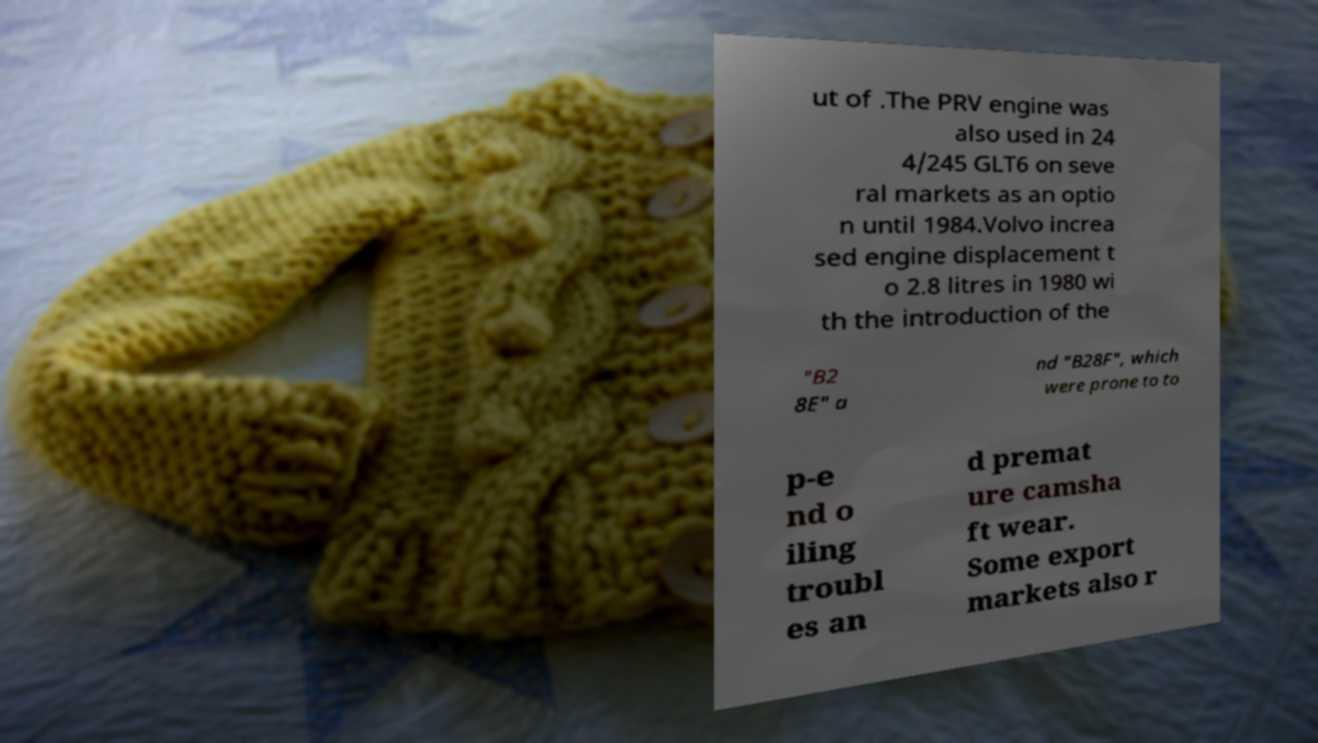I need the written content from this picture converted into text. Can you do that? ut of .The PRV engine was also used in 24 4/245 GLT6 on seve ral markets as an optio n until 1984.Volvo increa sed engine displacement t o 2.8 litres in 1980 wi th the introduction of the "B2 8E" a nd "B28F", which were prone to to p-e nd o iling troubl es an d premat ure camsha ft wear. Some export markets also r 